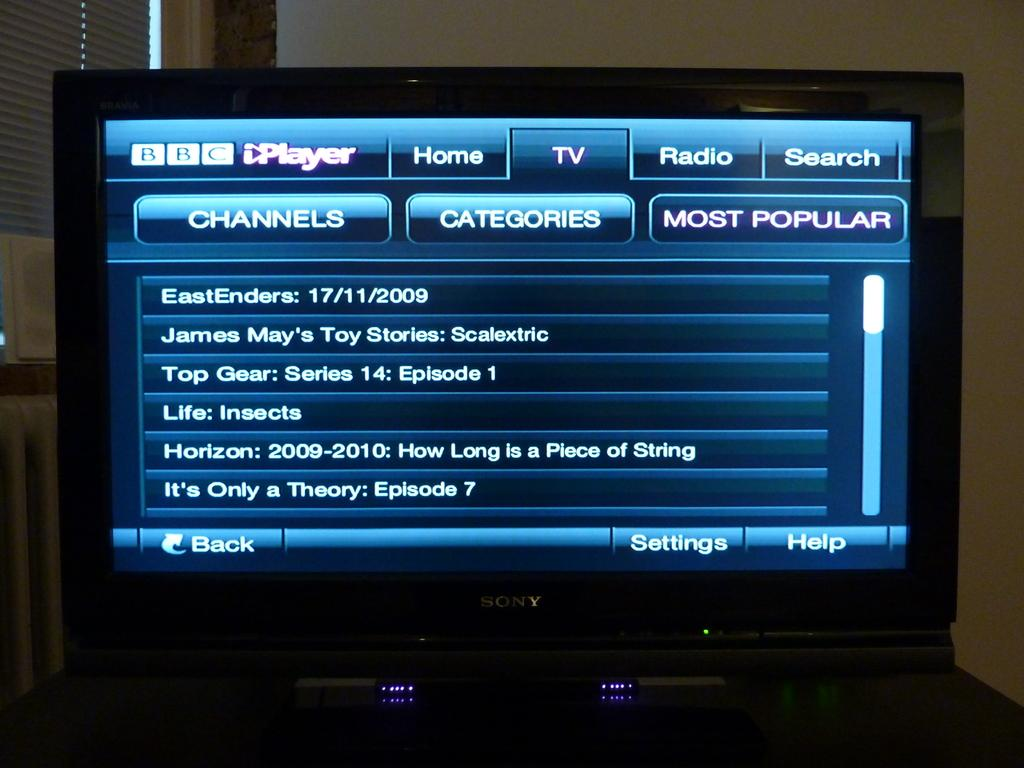<image>
Give a short and clear explanation of the subsequent image. BBC iPlayer with tabs for channels, categories and most popular. 